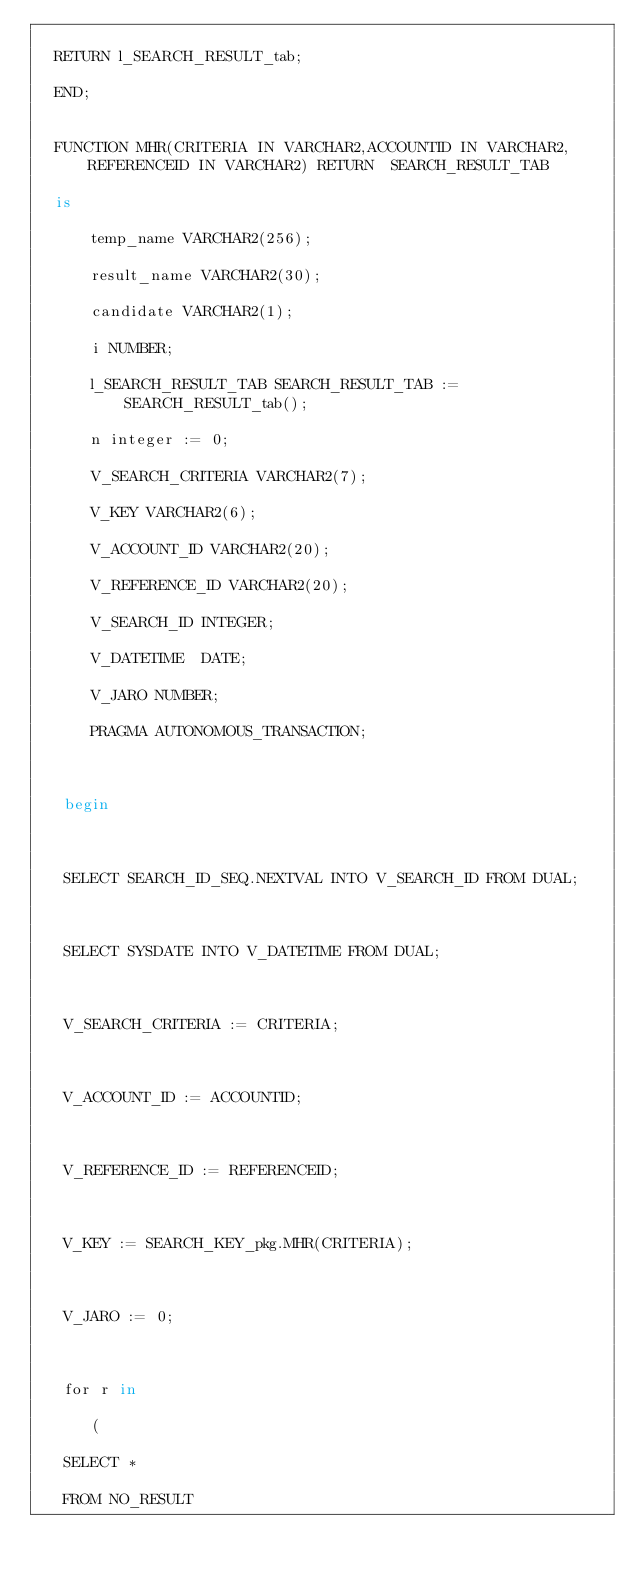Convert code to text. <code><loc_0><loc_0><loc_500><loc_500><_SQL_>      
  RETURN l_SEARCH_RESULT_tab;
      
  END;

   
  FUNCTION MHR(CRITERIA IN VARCHAR2,ACCOUNTID IN VARCHAR2,REFERENCEID IN VARCHAR2) RETURN  SEARCH_RESULT_TAB

  is

      temp_name VARCHAR2(256);

      result_name VARCHAR2(30);

      candidate VARCHAR2(1);

      i NUMBER;

      l_SEARCH_RESULT_TAB SEARCH_RESULT_TAB := SEARCH_RESULT_tab();

      n integer := 0;

      V_SEARCH_CRITERIA VARCHAR2(7);

      V_KEY VARCHAR2(6);

      V_ACCOUNT_ID VARCHAR2(20);

      V_REFERENCE_ID VARCHAR2(20);

      V_SEARCH_ID INTEGER;

      V_DATETIME  DATE;

      V_JARO NUMBER;

      PRAGMA AUTONOMOUS_TRANSACTION;

     

   begin

  

   SELECT SEARCH_ID_SEQ.NEXTVAL INTO V_SEARCH_ID FROM DUAL;

  

   SELECT SYSDATE INTO V_DATETIME FROM DUAL;

  

   V_SEARCH_CRITERIA := CRITERIA;

  

   V_ACCOUNT_ID := ACCOUNTID;

 

   V_REFERENCE_ID := REFERENCEID;

  

   V_KEY := SEARCH_KEY_pkg.MHR(CRITERIA);

  

   V_JARO := 0;

            

   for r in

      (

   SELECT *

   FROM NO_RESULT
</code> 